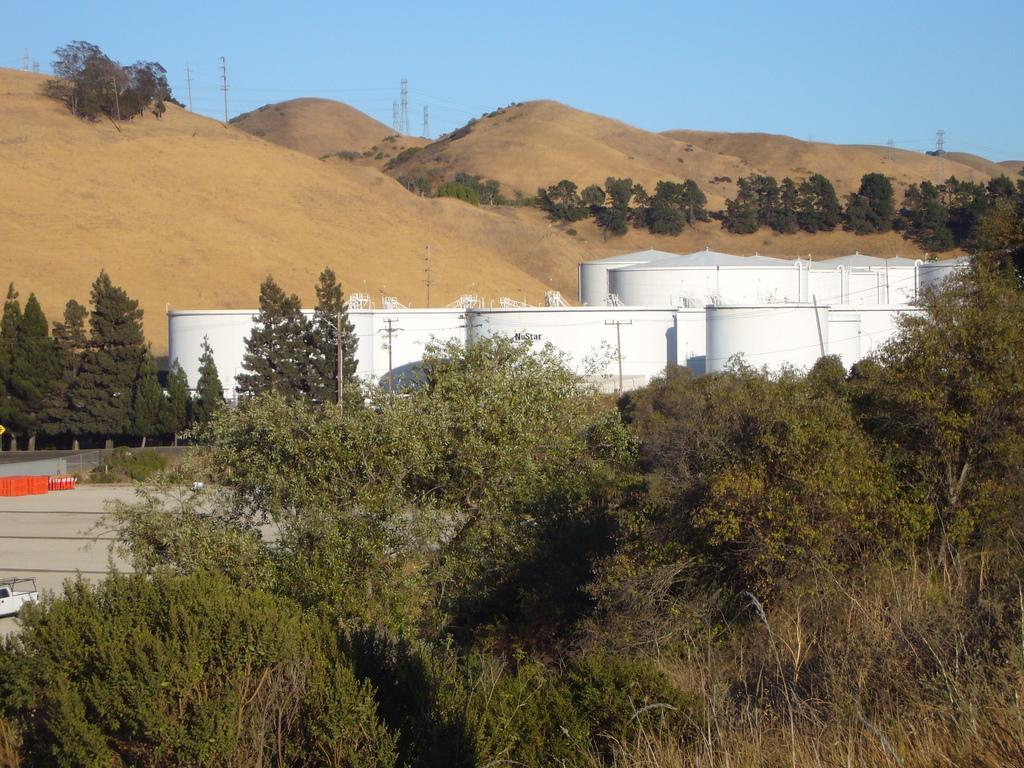In one or two sentences, can you explain what this image depicts? In this picture we can see few trees and containers, in the background we can find few towers. 